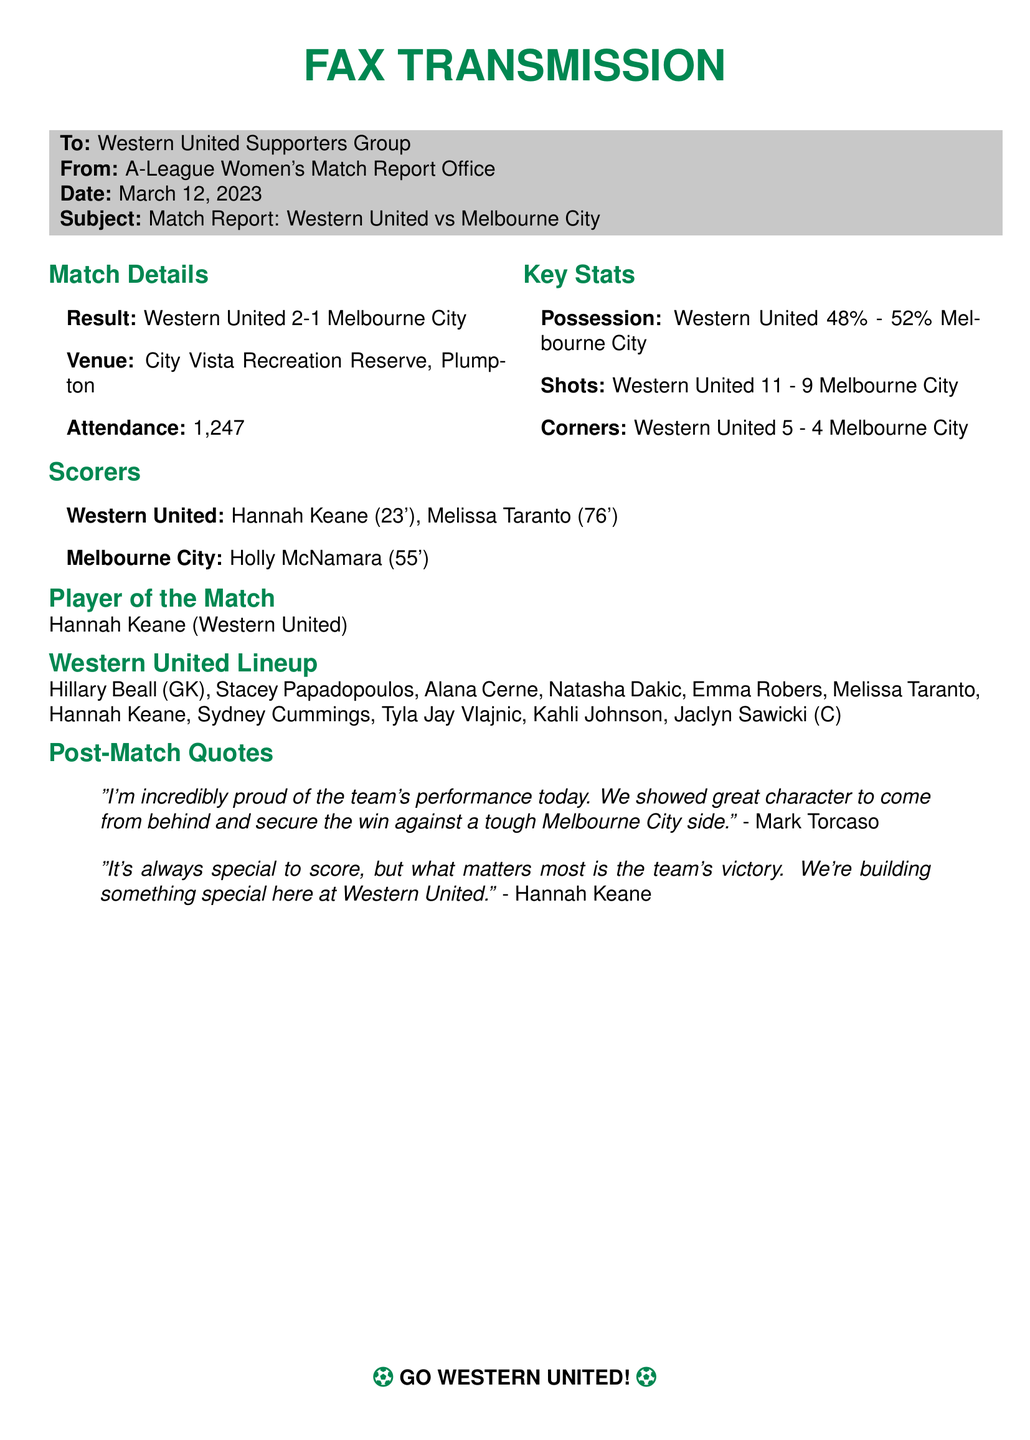what was the final score of the match? The final score is presented in the 'Result' section of the document, which lists Western United's score first and then Melbourne City's score.
Answer: Western United 2-1 Melbourne City who scored the first goal for Western United? The first goal scorer for Western United is mentioned in the 'Scorers' section, listing the goals in the order they were scored.
Answer: Hannah Keane how many shots did Western United have? The total number of shots taken by Western United is specified in the 'Key Stats' section, comparing their stats to those of Melbourne City.
Answer: 11 who is the Player of the Match? The 'Player of the Match' is clearly stated in a dedicated section of the document highlighting individual accomplishments.
Answer: Hannah Keane what is the attendance figure for the match? The number of attendees is indicated in the 'Match Details' section, reflecting the number of fans present at the venue.
Answer: 1,247 what venue hosted the match? The venue is mentioned in the 'Match Details' section under the title 'Venue', providing the location of the game.
Answer: City Vista Recreation Reserve, Plumpton which team had higher possession? Possession statistics can be found in the 'Key Stats' section, comparing both teams' ball control during the match.
Answer: Melbourne City what did Mark Torcaso say after the match? Mark Torcaso's post-match quote is contained in the 'Post-Match Quotes' section, summarizing his thoughts on the game.
Answer: "I'm incredibly proud of the team's performance today. We showed great character to come from behind and secure the win against a tough Melbourne City side." 